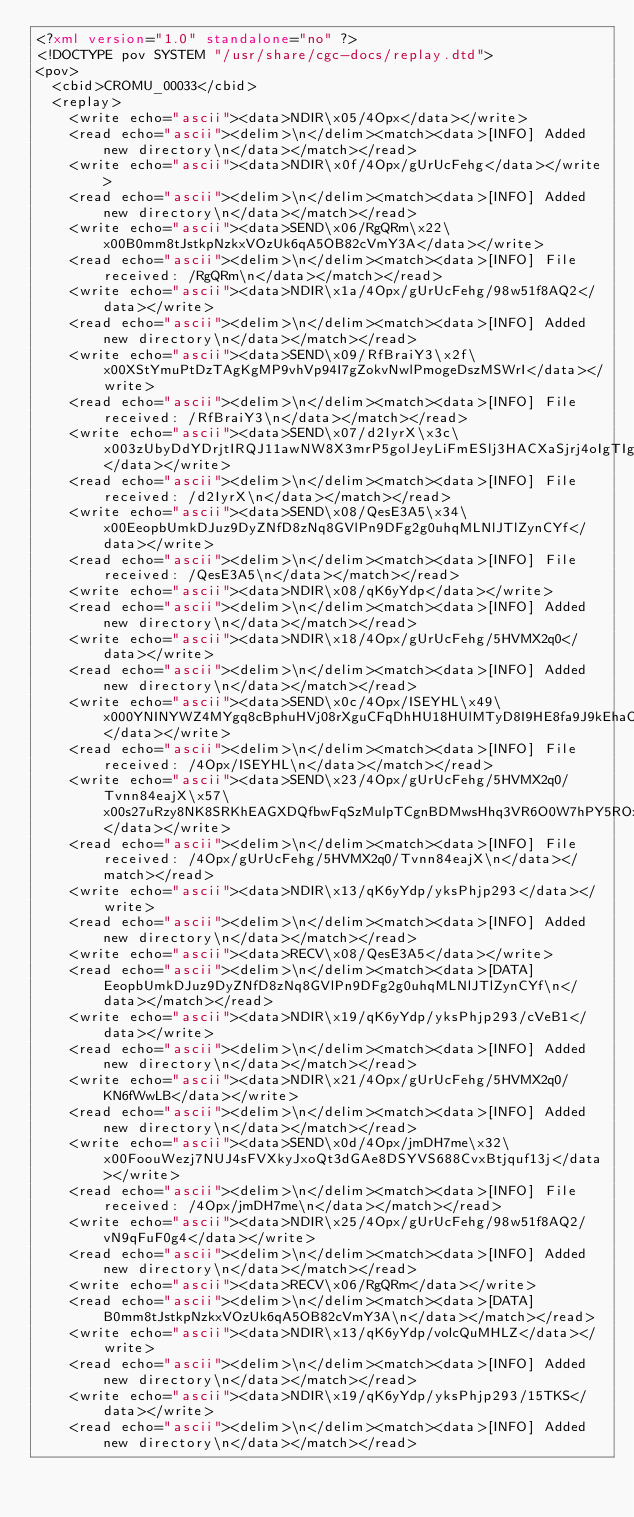<code> <loc_0><loc_0><loc_500><loc_500><_XML_><?xml version="1.0" standalone="no" ?>
<!DOCTYPE pov SYSTEM "/usr/share/cgc-docs/replay.dtd">
<pov>
	<cbid>CROMU_00033</cbid>
	<replay>
		<write echo="ascii"><data>NDIR\x05/4Opx</data></write>
		<read echo="ascii"><delim>\n</delim><match><data>[INFO] Added new directory\n</data></match></read>
		<write echo="ascii"><data>NDIR\x0f/4Opx/gUrUcFehg</data></write>
		<read echo="ascii"><delim>\n</delim><match><data>[INFO] Added new directory\n</data></match></read>
		<write echo="ascii"><data>SEND\x06/RgQRm\x22\x00B0mm8tJstkpNzkxVOzUk6qA5OB82cVmY3A</data></write>
		<read echo="ascii"><delim>\n</delim><match><data>[INFO] File received: /RgQRm\n</data></match></read>
		<write echo="ascii"><data>NDIR\x1a/4Opx/gUrUcFehg/98w51f8AQ2</data></write>
		<read echo="ascii"><delim>\n</delim><match><data>[INFO] Added new directory\n</data></match></read>
		<write echo="ascii"><data>SEND\x09/RfBraiY3\x2f\x00XStYmuPtDzTAgKgMP9vhVp94I7gZokvNwlPmogeDszMSWrI</data></write>
		<read echo="ascii"><delim>\n</delim><match><data>[INFO] File received: /RfBraiY3\n</data></match></read>
		<write echo="ascii"><data>SEND\x07/d2IyrX\x3c\x003zUbyDdYDrjtIRQJ11awNW8X3mrP5golJeyLiFmESlj3HACXaSjrj4oIgTIg</data></write>
		<read echo="ascii"><delim>\n</delim><match><data>[INFO] File received: /d2IyrX\n</data></match></read>
		<write echo="ascii"><data>SEND\x08/QesE3A5\x34\x00EeopbUmkDJuz9DyZNfD8zNq8GVlPn9DFg2g0uhqMLNlJTlZynCYf</data></write>
		<read echo="ascii"><delim>\n</delim><match><data>[INFO] File received: /QesE3A5\n</data></match></read>
		<write echo="ascii"><data>NDIR\x08/qK6yYdp</data></write>
		<read echo="ascii"><delim>\n</delim><match><data>[INFO] Added new directory\n</data></match></read>
		<write echo="ascii"><data>NDIR\x18/4Opx/gUrUcFehg/5HVMX2q0</data></write>
		<read echo="ascii"><delim>\n</delim><match><data>[INFO] Added new directory\n</data></match></read>
		<write echo="ascii"><data>SEND\x0c/4Opx/ISEYHL\x49\x000YNINYWZ4MYgq8cBphuHVj08rXguCFqDhHU18HUlMTyD8I9HE8fa9J9kEhaO5BNKHgexBJtXf</data></write>
		<read echo="ascii"><delim>\n</delim><match><data>[INFO] File received: /4Opx/ISEYHL\n</data></match></read>
		<write echo="ascii"><data>SEND\x23/4Opx/gUrUcFehg/5HVMX2q0/Tvnn84eajX\x57\x00s27uRzy8NK8SRKhEAGXDQfbwFqSzMulpTCgnBDMwsHhq3VR6O0W7hPY5ROxx1LsBNbzIieVmlARLEWNtOkPbE3f</data></write>
		<read echo="ascii"><delim>\n</delim><match><data>[INFO] File received: /4Opx/gUrUcFehg/5HVMX2q0/Tvnn84eajX\n</data></match></read>
		<write echo="ascii"><data>NDIR\x13/qK6yYdp/yksPhjp293</data></write>
		<read echo="ascii"><delim>\n</delim><match><data>[INFO] Added new directory\n</data></match></read>
		<write echo="ascii"><data>RECV\x08/QesE3A5</data></write>
		<read echo="ascii"><delim>\n</delim><match><data>[DATA] EeopbUmkDJuz9DyZNfD8zNq8GVlPn9DFg2g0uhqMLNlJTlZynCYf\n</data></match></read>
		<write echo="ascii"><data>NDIR\x19/qK6yYdp/yksPhjp293/cVeB1</data></write>
		<read echo="ascii"><delim>\n</delim><match><data>[INFO] Added new directory\n</data></match></read>
		<write echo="ascii"><data>NDIR\x21/4Opx/gUrUcFehg/5HVMX2q0/KN6fWwLB</data></write>
		<read echo="ascii"><delim>\n</delim><match><data>[INFO] Added new directory\n</data></match></read>
		<write echo="ascii"><data>SEND\x0d/4Opx/jmDH7me\x32\x00FoouWezj7NUJ4sFVXkyJxoQt3dGAe8DSYVS688CvxBtjquf13j</data></write>
		<read echo="ascii"><delim>\n</delim><match><data>[INFO] File received: /4Opx/jmDH7me\n</data></match></read>
		<write echo="ascii"><data>NDIR\x25/4Opx/gUrUcFehg/98w51f8AQ2/vN9qFuF0g4</data></write>
		<read echo="ascii"><delim>\n</delim><match><data>[INFO] Added new directory\n</data></match></read>
		<write echo="ascii"><data>RECV\x06/RgQRm</data></write>
		<read echo="ascii"><delim>\n</delim><match><data>[DATA] B0mm8tJstkpNzkxVOzUk6qA5OB82cVmY3A\n</data></match></read>
		<write echo="ascii"><data>NDIR\x13/qK6yYdp/volcQuMHLZ</data></write>
		<read echo="ascii"><delim>\n</delim><match><data>[INFO] Added new directory\n</data></match></read>
		<write echo="ascii"><data>NDIR\x19/qK6yYdp/yksPhjp293/15TKS</data></write>
		<read echo="ascii"><delim>\n</delim><match><data>[INFO] Added new directory\n</data></match></read></code> 